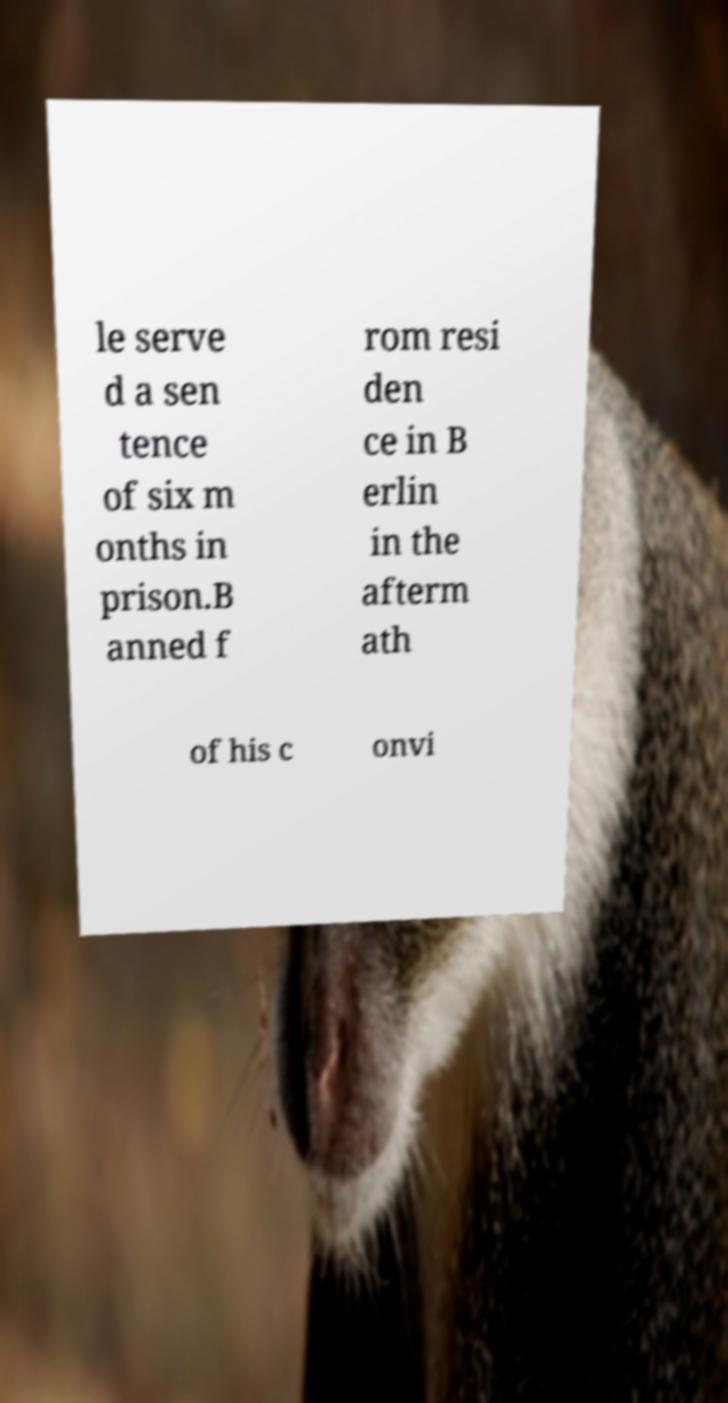What messages or text are displayed in this image? I need them in a readable, typed format. le serve d a sen tence of six m onths in prison.B anned f rom resi den ce in B erlin in the afterm ath of his c onvi 